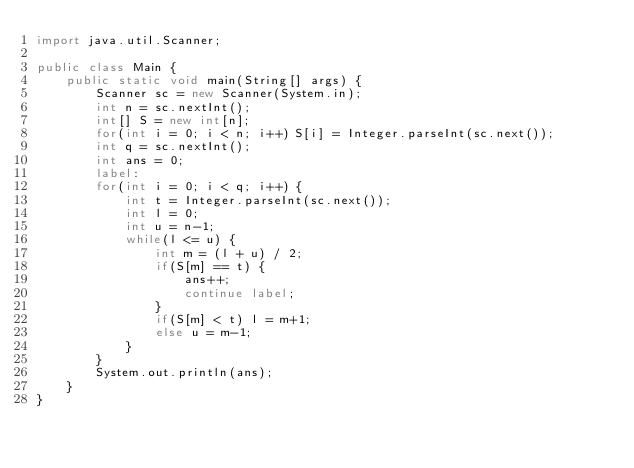Convert code to text. <code><loc_0><loc_0><loc_500><loc_500><_Java_>import java.util.Scanner;

public class Main {
    public static void main(String[] args) {
        Scanner sc = new Scanner(System.in);
        int n = sc.nextInt();
        int[] S = new int[n];
        for(int i = 0; i < n; i++) S[i] = Integer.parseInt(sc.next());
        int q = sc.nextInt();
        int ans = 0;
        label:
        for(int i = 0; i < q; i++) {
            int t = Integer.parseInt(sc.next());
            int l = 0;
            int u = n-1;
            while(l <= u) {
                int m = (l + u) / 2;
                if(S[m] == t) {
                    ans++;
                    continue label;
                }
                if(S[m] < t) l = m+1;
                else u = m-1;
            }
        }
        System.out.println(ans);
    }
}
</code> 